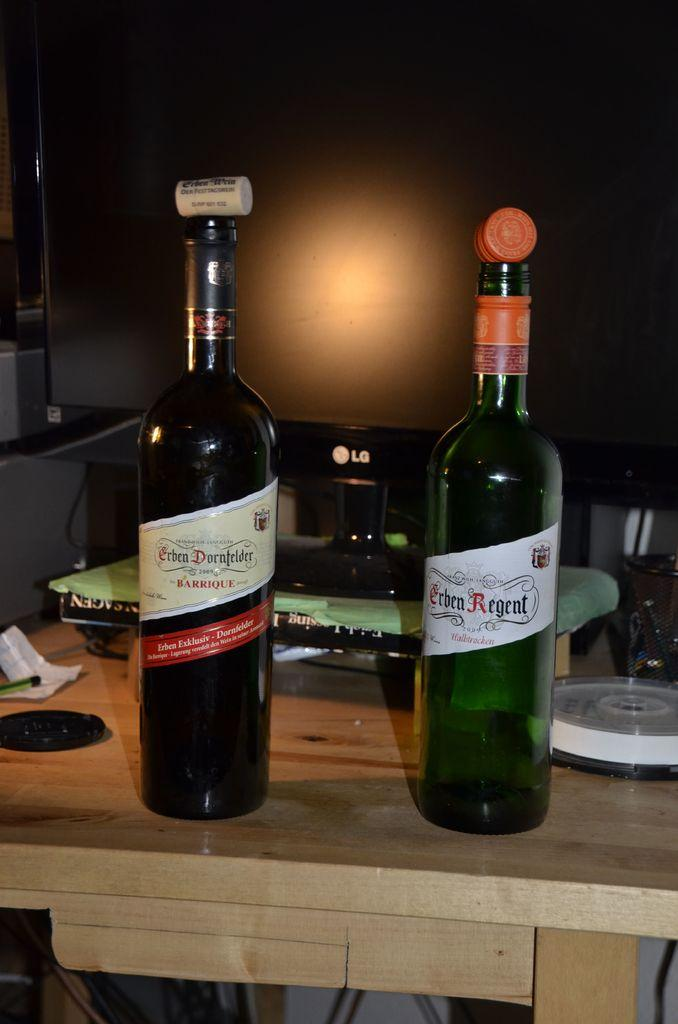How many bottles can be seen in the image? There are two bottles in the image. Where are the bottles located? The bottles are placed on a table. What might the purpose of the bottles be in the image? The bottles are likely used for an experiment. What type of organization is depicted in the image? There is no organization depicted in the image; it only features two bottles on a table. What is the breakfast item being served in the image? There is no breakfast item present in the image; it only features two bottles on a table. 